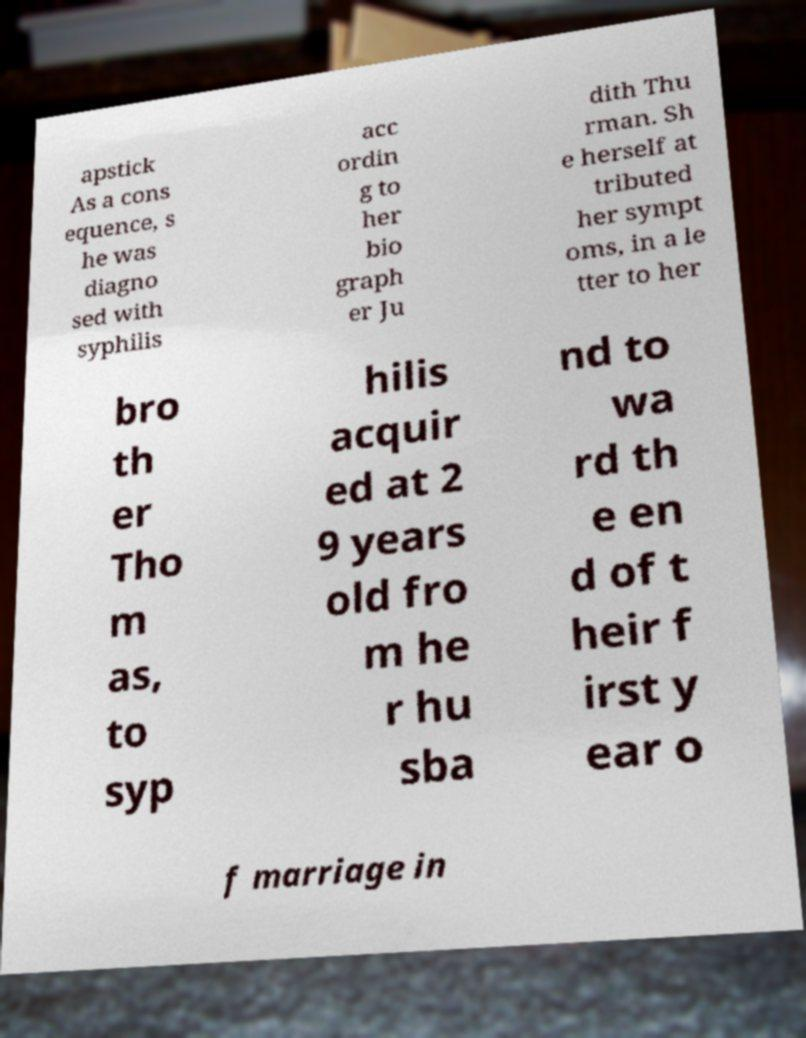For documentation purposes, I need the text within this image transcribed. Could you provide that? apstick As a cons equence, s he was diagno sed with syphilis acc ordin g to her bio graph er Ju dith Thu rman. Sh e herself at tributed her sympt oms, in a le tter to her bro th er Tho m as, to syp hilis acquir ed at 2 9 years old fro m he r hu sba nd to wa rd th e en d of t heir f irst y ear o f marriage in 